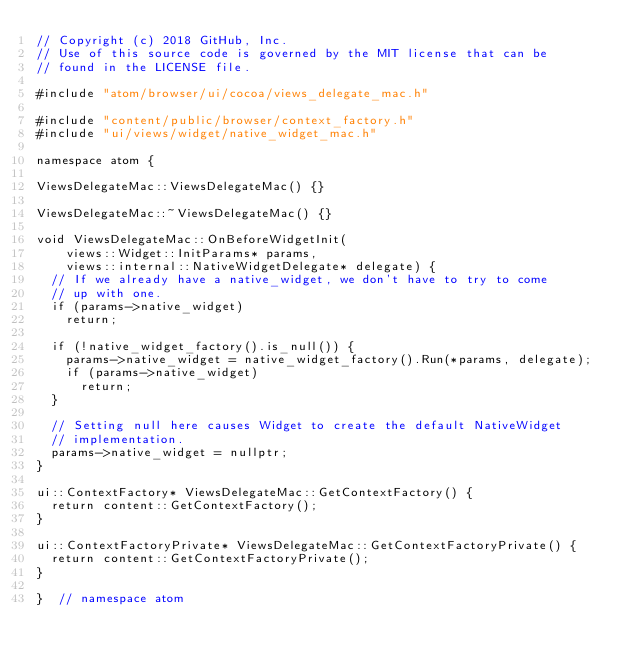Convert code to text. <code><loc_0><loc_0><loc_500><loc_500><_ObjectiveC_>// Copyright (c) 2018 GitHub, Inc.
// Use of this source code is governed by the MIT license that can be
// found in the LICENSE file.

#include "atom/browser/ui/cocoa/views_delegate_mac.h"

#include "content/public/browser/context_factory.h"
#include "ui/views/widget/native_widget_mac.h"

namespace atom {

ViewsDelegateMac::ViewsDelegateMac() {}

ViewsDelegateMac::~ViewsDelegateMac() {}

void ViewsDelegateMac::OnBeforeWidgetInit(
    views::Widget::InitParams* params,
    views::internal::NativeWidgetDelegate* delegate) {
  // If we already have a native_widget, we don't have to try to come
  // up with one.
  if (params->native_widget)
    return;

  if (!native_widget_factory().is_null()) {
    params->native_widget = native_widget_factory().Run(*params, delegate);
    if (params->native_widget)
      return;
  }

  // Setting null here causes Widget to create the default NativeWidget
  // implementation.
  params->native_widget = nullptr;
}

ui::ContextFactory* ViewsDelegateMac::GetContextFactory() {
  return content::GetContextFactory();
}

ui::ContextFactoryPrivate* ViewsDelegateMac::GetContextFactoryPrivate() {
  return content::GetContextFactoryPrivate();
}

}  // namespace atom
</code> 